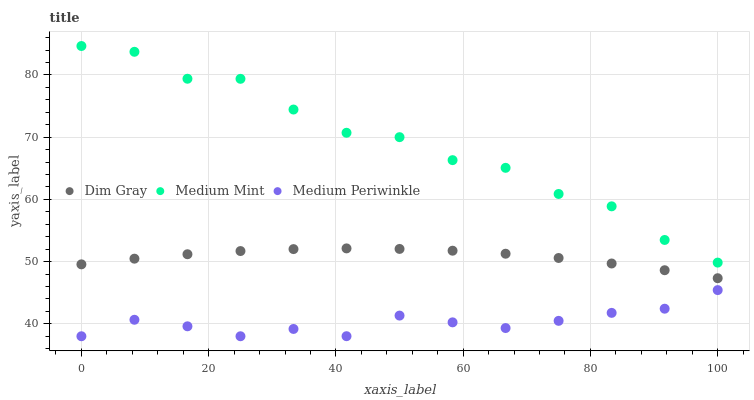Does Medium Periwinkle have the minimum area under the curve?
Answer yes or no. Yes. Does Medium Mint have the maximum area under the curve?
Answer yes or no. Yes. Does Dim Gray have the minimum area under the curve?
Answer yes or no. No. Does Dim Gray have the maximum area under the curve?
Answer yes or no. No. Is Dim Gray the smoothest?
Answer yes or no. Yes. Is Medium Mint the roughest?
Answer yes or no. Yes. Is Medium Periwinkle the smoothest?
Answer yes or no. No. Is Medium Periwinkle the roughest?
Answer yes or no. No. Does Medium Periwinkle have the lowest value?
Answer yes or no. Yes. Does Dim Gray have the lowest value?
Answer yes or no. No. Does Medium Mint have the highest value?
Answer yes or no. Yes. Does Dim Gray have the highest value?
Answer yes or no. No. Is Medium Periwinkle less than Medium Mint?
Answer yes or no. Yes. Is Dim Gray greater than Medium Periwinkle?
Answer yes or no. Yes. Does Medium Periwinkle intersect Medium Mint?
Answer yes or no. No. 